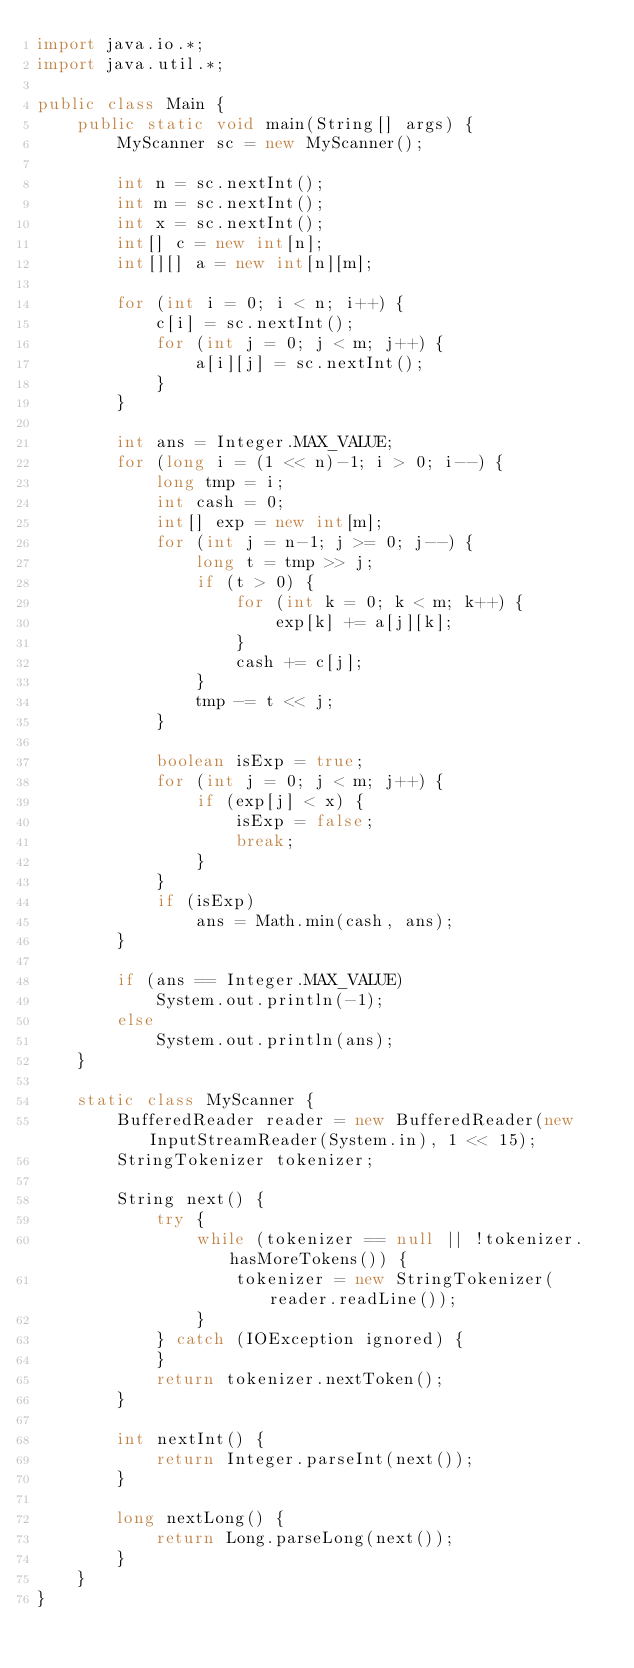Convert code to text. <code><loc_0><loc_0><loc_500><loc_500><_Java_>import java.io.*;
import java.util.*;

public class Main {
    public static void main(String[] args) {
        MyScanner sc = new MyScanner();

        int n = sc.nextInt();
        int m = sc.nextInt();
        int x = sc.nextInt();
        int[] c = new int[n];
        int[][] a = new int[n][m];

        for (int i = 0; i < n; i++) {
            c[i] = sc.nextInt();
            for (int j = 0; j < m; j++) {
                a[i][j] = sc.nextInt();
            }
        }

        int ans = Integer.MAX_VALUE;
        for (long i = (1 << n)-1; i > 0; i--) {
            long tmp = i;
            int cash = 0;
            int[] exp = new int[m];
            for (int j = n-1; j >= 0; j--) {
                long t = tmp >> j;
                if (t > 0) {
                    for (int k = 0; k < m; k++) {
                        exp[k] += a[j][k];
                    }
                    cash += c[j];
                }
                tmp -= t << j;
            }

            boolean isExp = true;
            for (int j = 0; j < m; j++) {
                if (exp[j] < x) {
                    isExp = false;
                    break;
                }
            }
            if (isExp)
                ans = Math.min(cash, ans);
        }

        if (ans == Integer.MAX_VALUE)
            System.out.println(-1);
        else
            System.out.println(ans);
    }

    static class MyScanner {
        BufferedReader reader = new BufferedReader(new InputStreamReader(System.in), 1 << 15);
        StringTokenizer tokenizer;

        String next() {
            try {
                while (tokenizer == null || !tokenizer.hasMoreTokens()) {
                    tokenizer = new StringTokenizer(reader.readLine());
                }
            } catch (IOException ignored) {
            }
            return tokenizer.nextToken();
        }

        int nextInt() {
            return Integer.parseInt(next());
        }

        long nextLong() {
            return Long.parseLong(next());
        }
    }
}</code> 